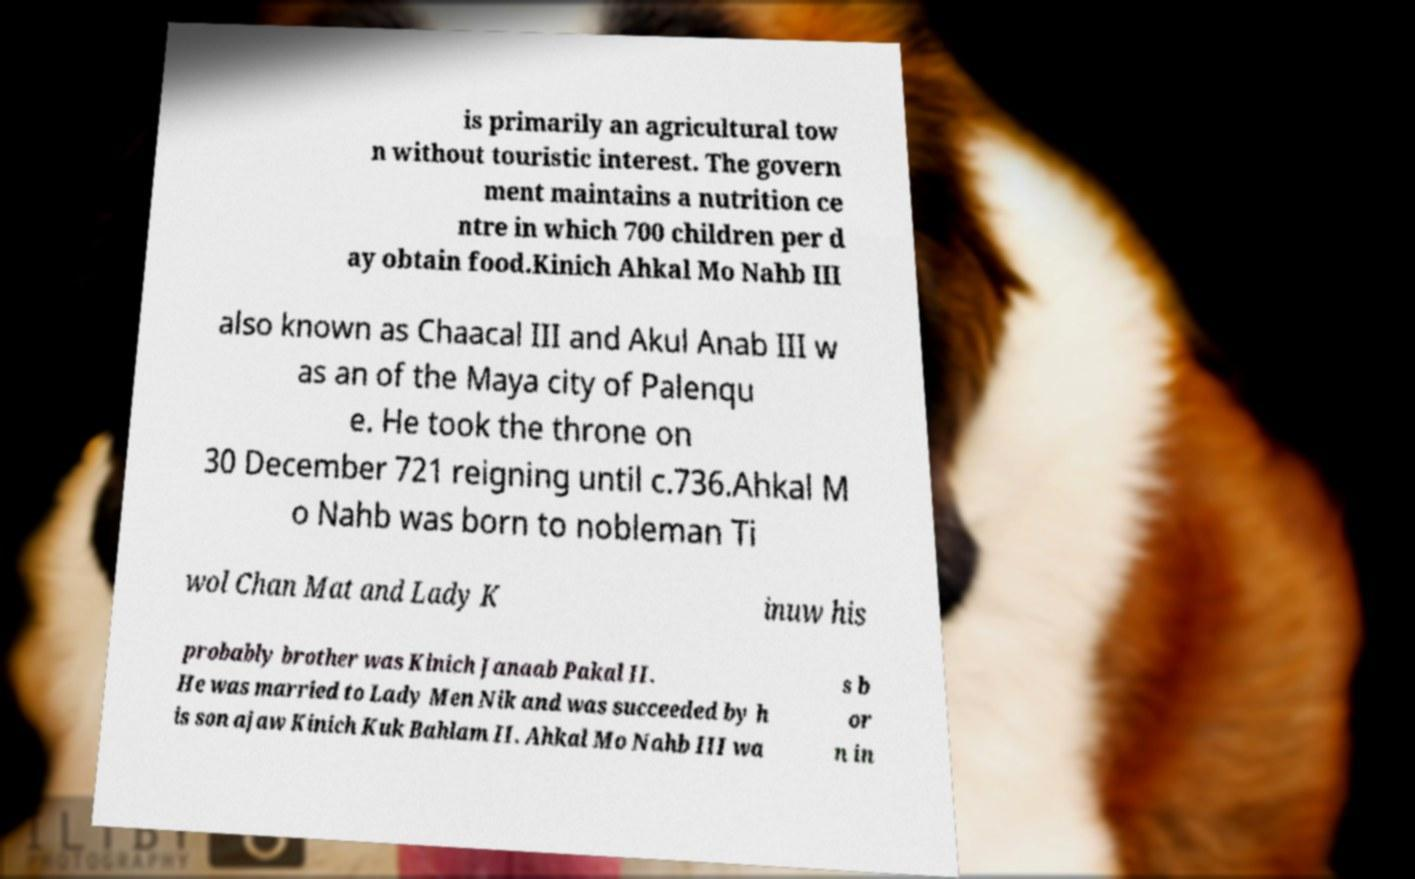Could you extract and type out the text from this image? is primarily an agricultural tow n without touristic interest. The govern ment maintains a nutrition ce ntre in which 700 children per d ay obtain food.Kinich Ahkal Mo Nahb III also known as Chaacal III and Akul Anab III w as an of the Maya city of Palenqu e. He took the throne on 30 December 721 reigning until c.736.Ahkal M o Nahb was born to nobleman Ti wol Chan Mat and Lady K inuw his probably brother was Kinich Janaab Pakal II. He was married to Lady Men Nik and was succeeded by h is son ajaw Kinich Kuk Bahlam II. Ahkal Mo Nahb III wa s b or n in 